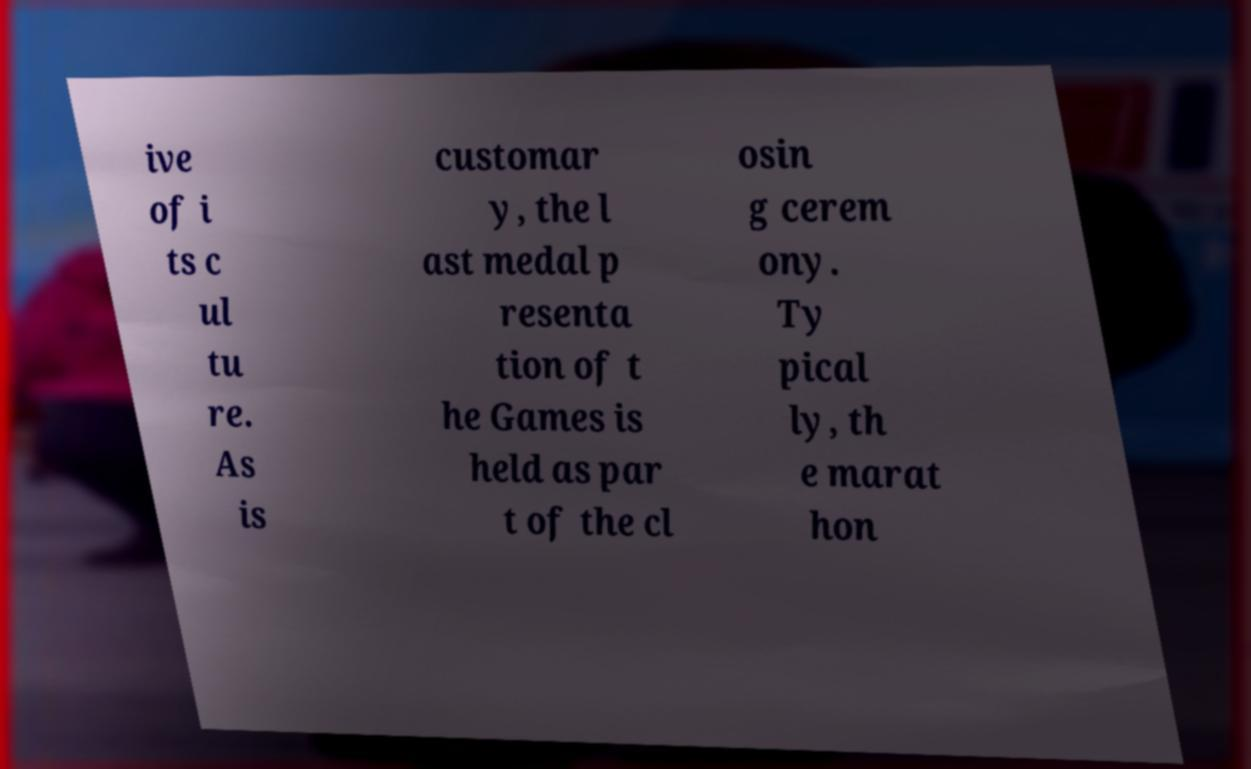Could you assist in decoding the text presented in this image and type it out clearly? ive of i ts c ul tu re. As is customar y, the l ast medal p resenta tion of t he Games is held as par t of the cl osin g cerem ony. Ty pical ly, th e marat hon 